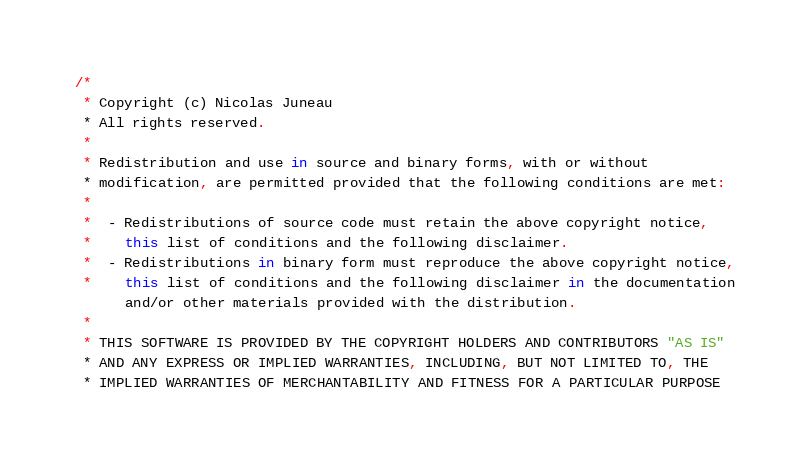<code> <loc_0><loc_0><loc_500><loc_500><_Haxe_>/*
 * Copyright (c) Nicolas Juneau
 * All rights reserved.
 *
 * Redistribution and use in source and binary forms, with or without
 * modification, are permitted provided that the following conditions are met:
 *
 *  - Redistributions of source code must retain the above copyright notice,
 *    this list of conditions and the following disclaimer.
 *  - Redistributions in binary form must reproduce the above copyright notice,
 *    this list of conditions and the following disclaimer in the documentation
      and/or other materials provided with the distribution.
 *
 * THIS SOFTWARE IS PROVIDED BY THE COPYRIGHT HOLDERS AND CONTRIBUTORS "AS IS"
 * AND ANY EXPRESS OR IMPLIED WARRANTIES, INCLUDING, BUT NOT LIMITED TO, THE
 * IMPLIED WARRANTIES OF MERCHANTABILITY AND FITNESS FOR A PARTICULAR PURPOSE</code> 